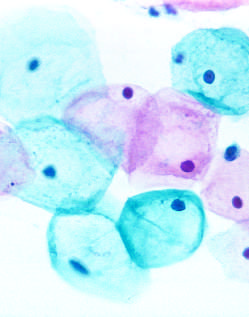re these cells exfoliated?
Answer the question using a single word or phrase. Yes 